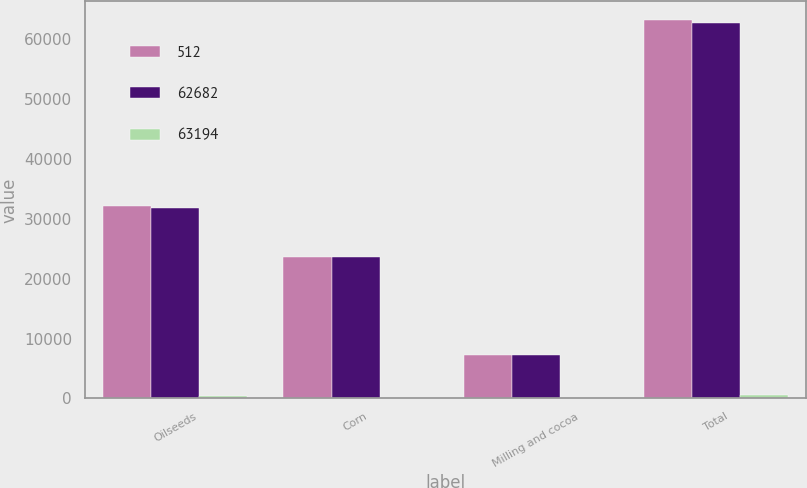Convert chart to OTSL. <chart><loc_0><loc_0><loc_500><loc_500><stacked_bar_chart><ecel><fcel>Oilseeds<fcel>Corn<fcel>Milling and cocoa<fcel>Total<nl><fcel>512<fcel>32208<fcel>23668<fcel>7318<fcel>63194<nl><fcel>62682<fcel>31768<fcel>23688<fcel>7226<fcel>62682<nl><fcel>63194<fcel>440<fcel>20<fcel>92<fcel>512<nl></chart> 